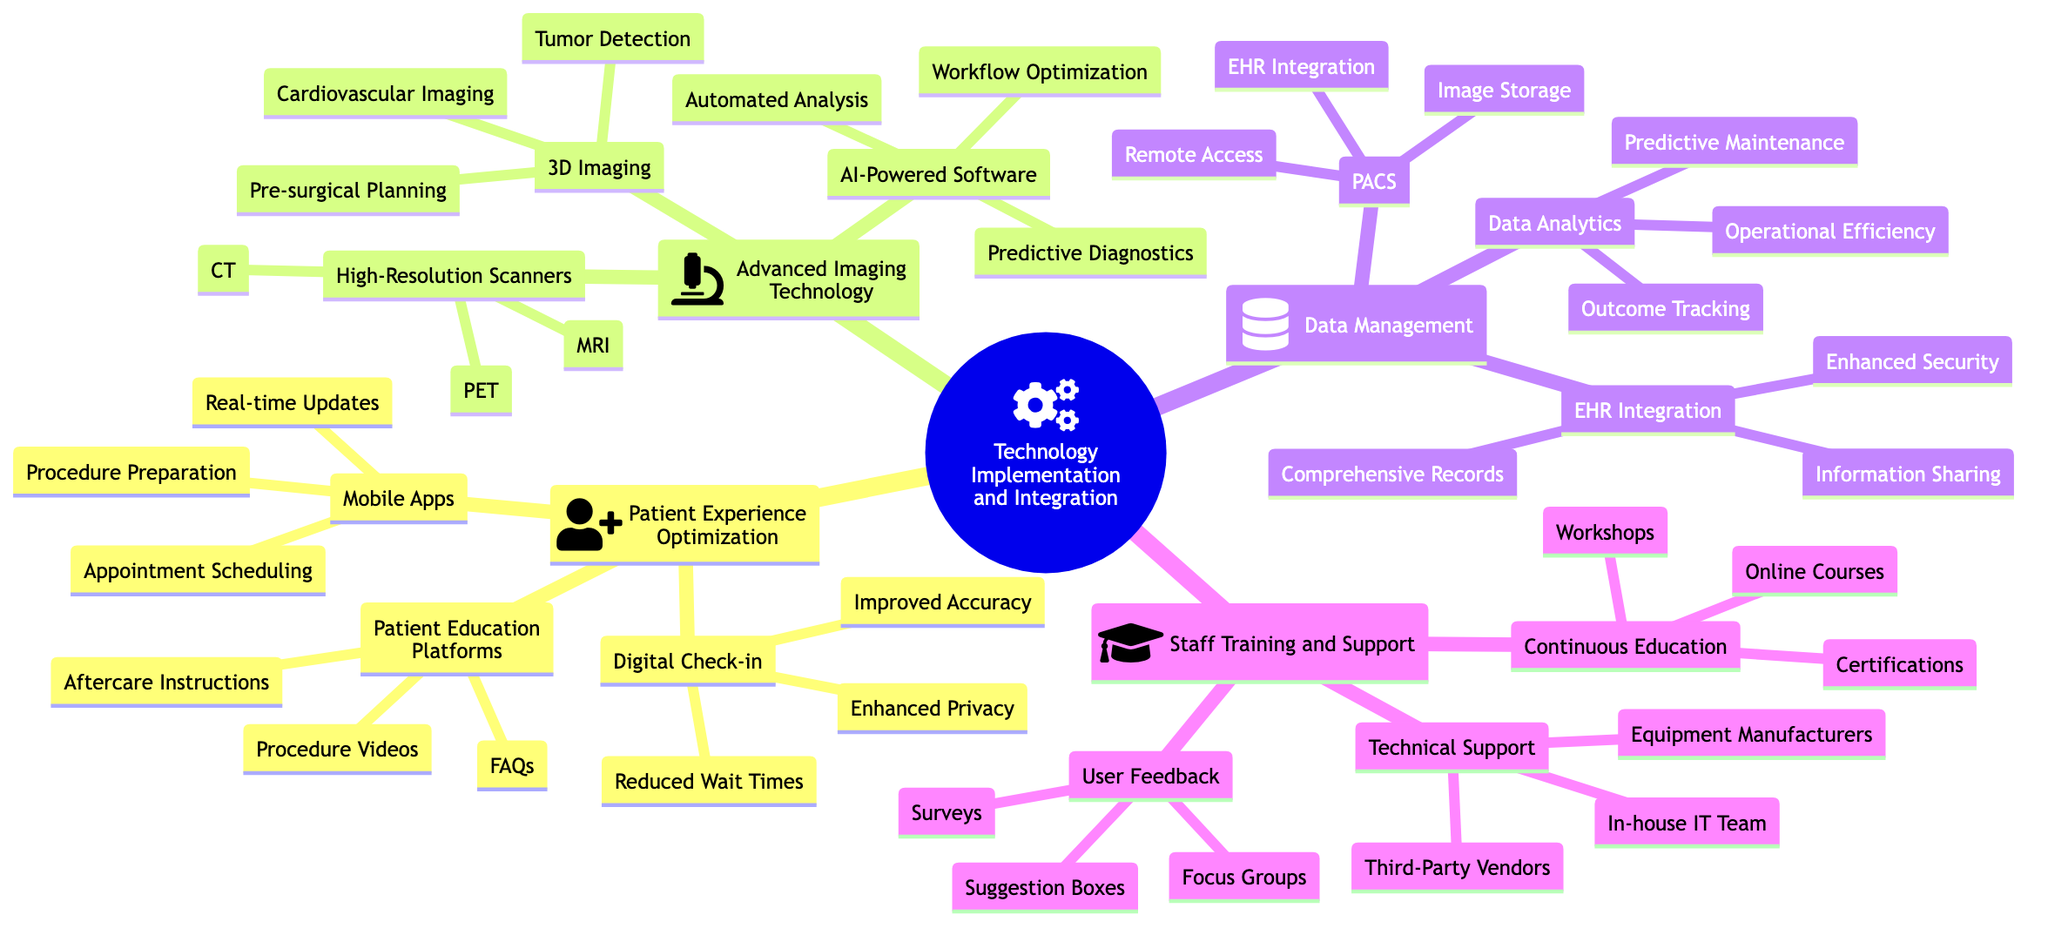What is the main category under which patient experience optimization falls? The main category is "Technology Implementation and Integration." This can be observed from the root node in the diagram where "Technology Implementation and Integration" is the starting point with various branches like "Patient Experience Optimization."
Answer: Technology Implementation and Integration How many types of high-resolution scanners are listed? There are three types listed under "High-Resolution Scanners": MRI, CT, and PET. This can be confirmed by counting the child nodes connected to the "High-Resolution Scanners" node.
Answer: 3 What applications are associated with 3D imaging? The applications associated with 3D imaging include Tumor Detection, Pre-surgical Planning, and Cardiovascular Imaging. This is directly taken from the node labeled "3D Imaging," which lists these three applications as its child nodes.
Answer: Tumor Detection, Pre-surgical Planning, Cardiovascular Imaging What benefits does EHR integration provide? EHR Integration provides three benefits: Comprehensive Patient Records, Streamlined Information Sharing, and Enhanced Data Security. These benefits can be found as child nodes under the "EHR Integration" node.
Answer: Comprehensive Patient Records, Streamlined Information Sharing, Enhanced Data Security What types of continuous education are available? The types of continuous education available include Online Courses, Workshops, and Certifications. This is directly visible under the "Continuous Education" node, where these three options are listed as its child nodes.
Answer: Online Courses, Workshops, Certifications Which type of support can a healthcare administrator seek for technical issues? A healthcare administrator can seek support from an In-house IT Team, Third-Party Vendors, or Equipment Manufacturers. This information is found under the "Technical Support" node, which lists these three types of support as its child nodes.
Answer: In-house IT Team, Third-Party Vendors, Equipment Manufacturers How many methods are mentioned for user feedback mechanisms? There are three methods mentioned for user feedback mechanisms: Surveys, Focus Groups, and Suggestion Boxes. This can be confirmed by counting the child nodes connected to the "User Feedback Mechanisms" node.
Answer: 3 What is the primary function of PACS? The primary functions of PACS include Image Storage, Remote Access, and EHR Integration. These functions are visible as child nodes under the "PACS" node, detailing what PACS provides.
Answer: Image Storage, Remote Access, EHR Integration 